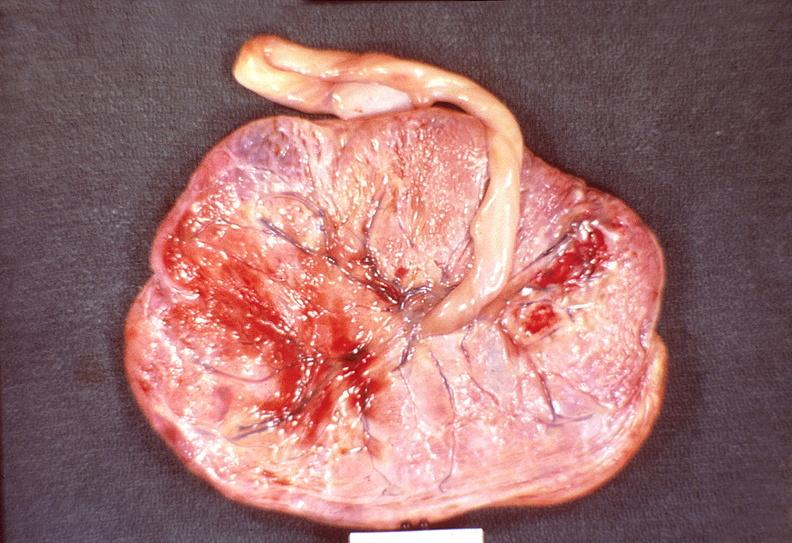does this image show placenta, congestion and hemorrhage, hemolytic disease of newborn?
Answer the question using a single word or phrase. Yes 